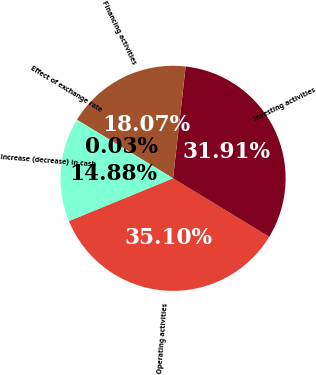Convert chart to OTSL. <chart><loc_0><loc_0><loc_500><loc_500><pie_chart><fcel>Operating activities<fcel>Investing activities<fcel>Financing activities<fcel>Effect of exchange rate<fcel>Increase (decrease) in cash<nl><fcel>35.1%<fcel>31.91%<fcel>18.07%<fcel>0.03%<fcel>14.88%<nl></chart> 